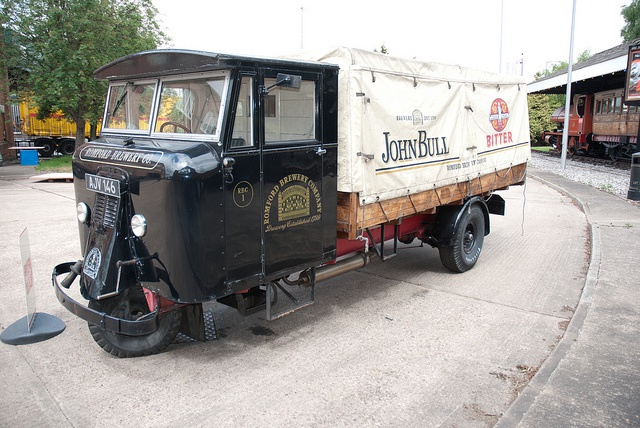Describe the objects in this image and their specific colors. I can see truck in darkgray, black, white, and gray tones and train in darkgray, black, gray, and maroon tones in this image. 